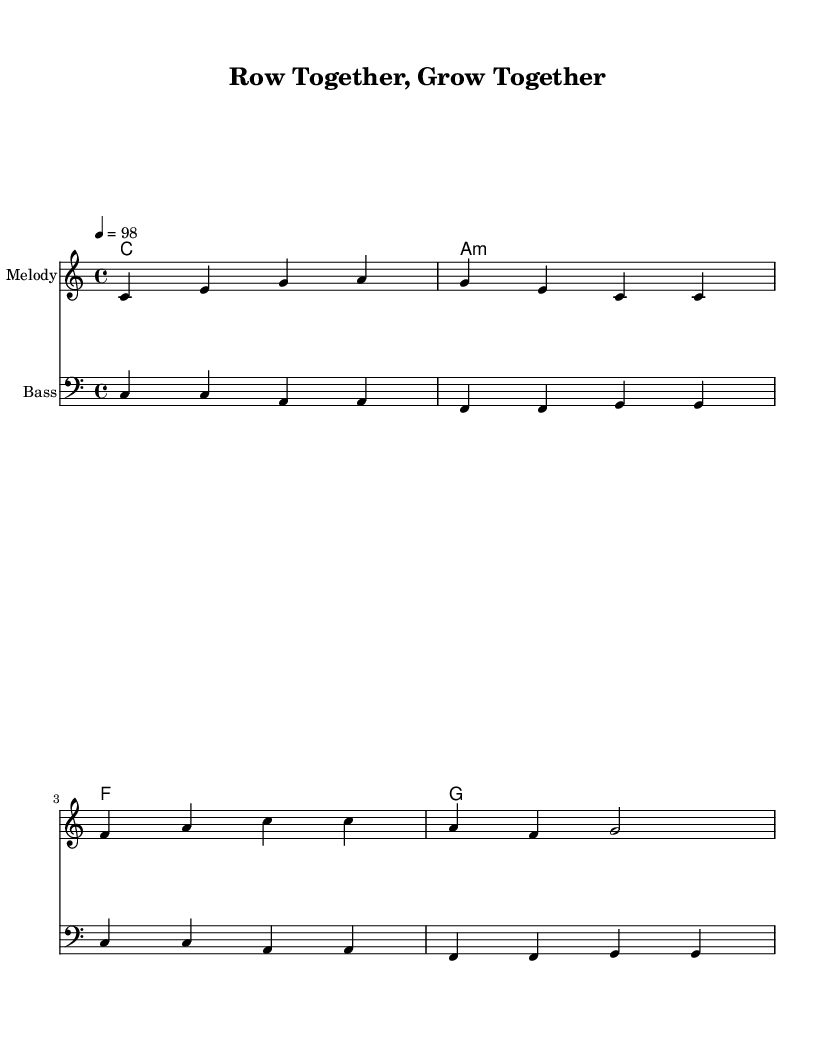What is the key signature of this music? The key signature is C major, which has no sharps or flats, as indicated before the staff.
Answer: C major What is the time signature of this music? The time signature is 4/4, which means there are four beats per measure with a quarter note receiving one beat. This is shown at the beginning of the piece.
Answer: 4/4 What is the tempo marking for this piece? The tempo marking indicates a speed of 98 beats per minute, shown by "4 = 98" in the global settings of the score.
Answer: 98 How many measures are in the melody? The melody consists of 8 measures, as counted by the groups of notes separated by vertical lines (bar lines).
Answer: 8 What is the chord progression used in the piece? The chord progression follows a pattern of C, A minor, F, and G, which is a common progression in many reggae songs to create a smooth and uplifting vibe.
Answer: C, A minor, F, G What genre of music is represented in this sheet? The sheet music style is upbeat reggae, characterized by its syncopated rhythms and positive themes, which matches the title and lyrical content.
Answer: Reggae What lyrical theme is highlighted in this piece? The lyrics promote teamwork and camaraderie, as depicted in the phrase "Row together, grow together," which embodies unity in sports and community activities.
Answer: Teamwork 